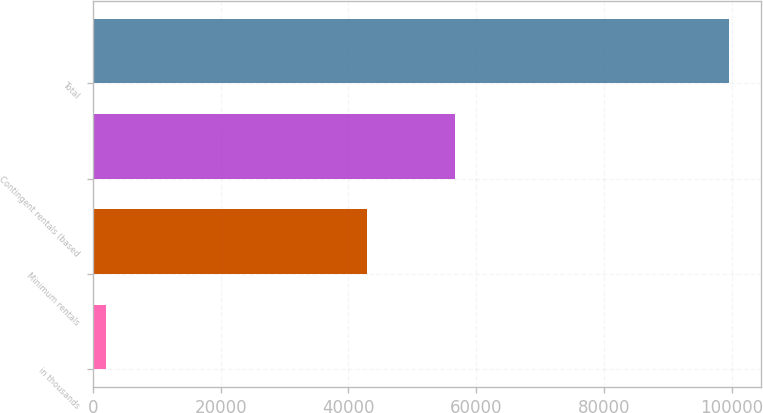<chart> <loc_0><loc_0><loc_500><loc_500><bar_chart><fcel>in thousands<fcel>Minimum rentals<fcel>Contingent rentals (based<fcel>Total<nl><fcel>2014<fcel>42887<fcel>56717<fcel>99604<nl></chart> 